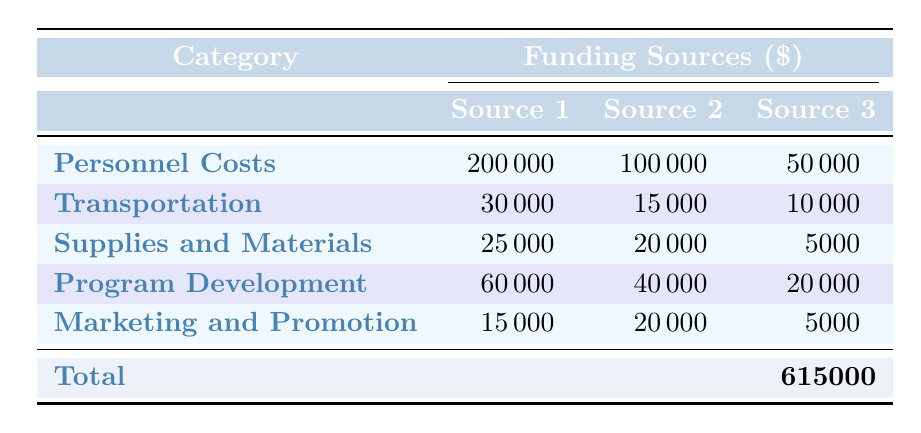What is the total amount allocated for Personnel Costs? The table lists the amount for Personnel Costs under the "Total Amount" row, which is specified as 350000.
Answer: 350000 How much funding comes from Local Government for Personnel Costs? The table shows the amount provided by Local Government for Personnel Costs, which is 50000.
Answer: 50000 What is the total funding amount for Transportation? The table provides the total amount for the Transportation category as 55000, located in the "Total Amount" row.
Answer: 55000 Which category has the highest total funding amount? By comparing the total amounts listed for each category, Personnel Costs has the highest total funding at 350000.
Answer: Personnel Costs What is the combined funding from State and Federal sources for Program Development? For Program Development, Federal sources (60000) and State sources (40000) sum to 60000 + 40000 = 100000.
Answer: 100000 Is the amount allocated for Marketing and Promotion higher than that for Supplies and Materials? Comparing the total amounts: Marketing and Promotion has 40000 and Supplies and Materials has 50000; since 40000 is less than 50000, the statement is false.
Answer: No What percentage of the overall budget is allocated to Program Development? The overall budget is 600000. Thus, Program Development which is 120000 is (120000 / 600000) * 100 = 20%.
Answer: 20% How much funding do PTA Contributions provide compared to Corporate Sponsors in Transportation? PTA Contributions provide 25000 in Supplies and Materials, while Corporate Sponsors in Transportation provide 10000. Comparing gives 25000 vs. 10000, and 25000 is greater.
Answer: 25000 is greater than 10000 What total amount is provided from donations (Donation Drives and Individual Donors) across both Transportation and Program Development? Donation Drives contribute 15000 in Transportation, and Individual Donors contribute 20000 in Program Development. Summing these gives 15000 + 20000 = 35000.
Answer: 35000 How much funding does the State Arts Council contribute overall compared to the total for Marketing and Promotion? The State Arts Council contributes 60000 in Program Development, while Marketing and Promotion sums to 40000; since 60000 is greater than 40000, the statement is true.
Answer: Yes 